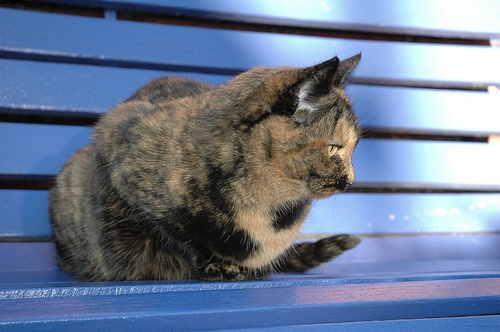Describe the objects in this image and their specific colors. I can see a cat in black and gray tones in this image. 